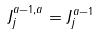Convert formula to latex. <formula><loc_0><loc_0><loc_500><loc_500>J ^ { a - 1 , a } _ { j } = J ^ { a - 1 } _ { j }</formula> 